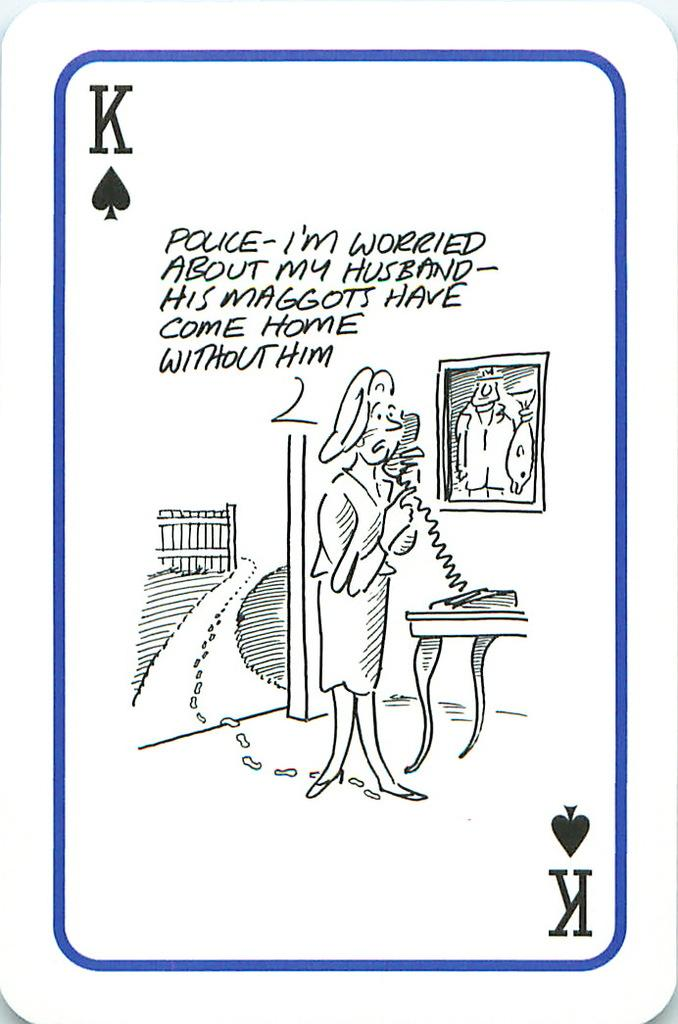What is the main subject in the image? There is a poster in the image. What news is being reported on the poster in the image? There is no news being reported on the poster in the image, as the provided fact does not mention any specific content or context. 